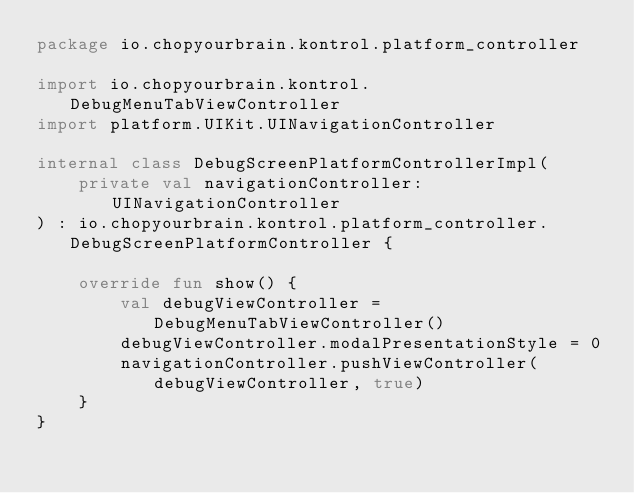<code> <loc_0><loc_0><loc_500><loc_500><_Kotlin_>package io.chopyourbrain.kontrol.platform_controller

import io.chopyourbrain.kontrol.DebugMenuTabViewController
import platform.UIKit.UINavigationController

internal class DebugScreenPlatformControllerImpl(
    private val navigationController: UINavigationController
) : io.chopyourbrain.kontrol.platform_controller.DebugScreenPlatformController {

    override fun show() {
        val debugViewController = DebugMenuTabViewController()
        debugViewController.modalPresentationStyle = 0
        navigationController.pushViewController(debugViewController, true)
    }
}
</code> 